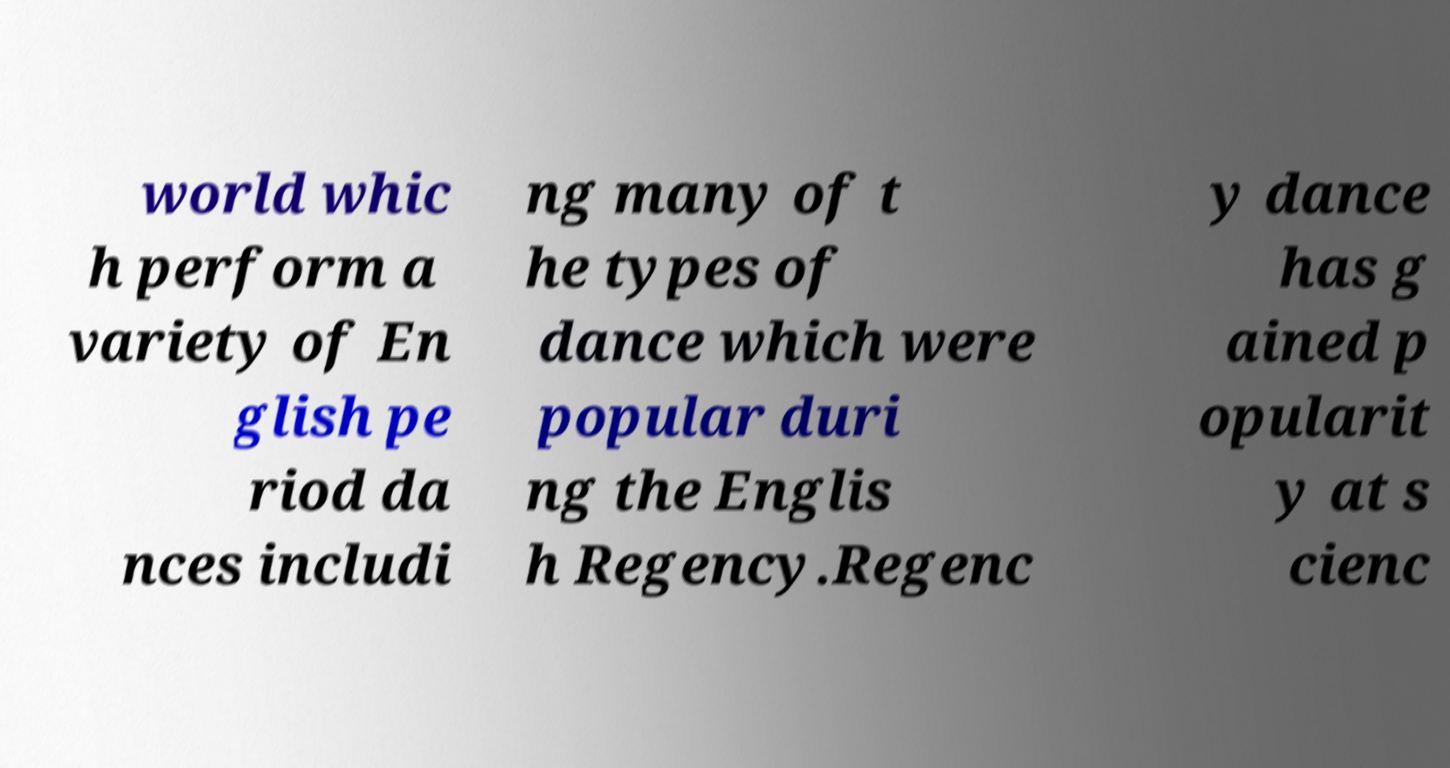Could you assist in decoding the text presented in this image and type it out clearly? world whic h perform a variety of En glish pe riod da nces includi ng many of t he types of dance which were popular duri ng the Englis h Regency.Regenc y dance has g ained p opularit y at s cienc 